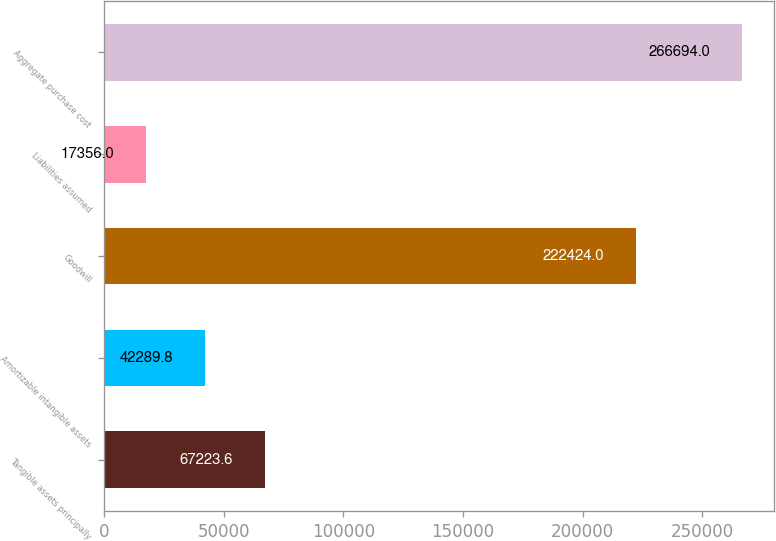Convert chart to OTSL. <chart><loc_0><loc_0><loc_500><loc_500><bar_chart><fcel>Tangible assets principally<fcel>Amortizable intangible assets<fcel>Goodwill<fcel>Liabilities assumed<fcel>Aggregate purchase cost<nl><fcel>67223.6<fcel>42289.8<fcel>222424<fcel>17356<fcel>266694<nl></chart> 